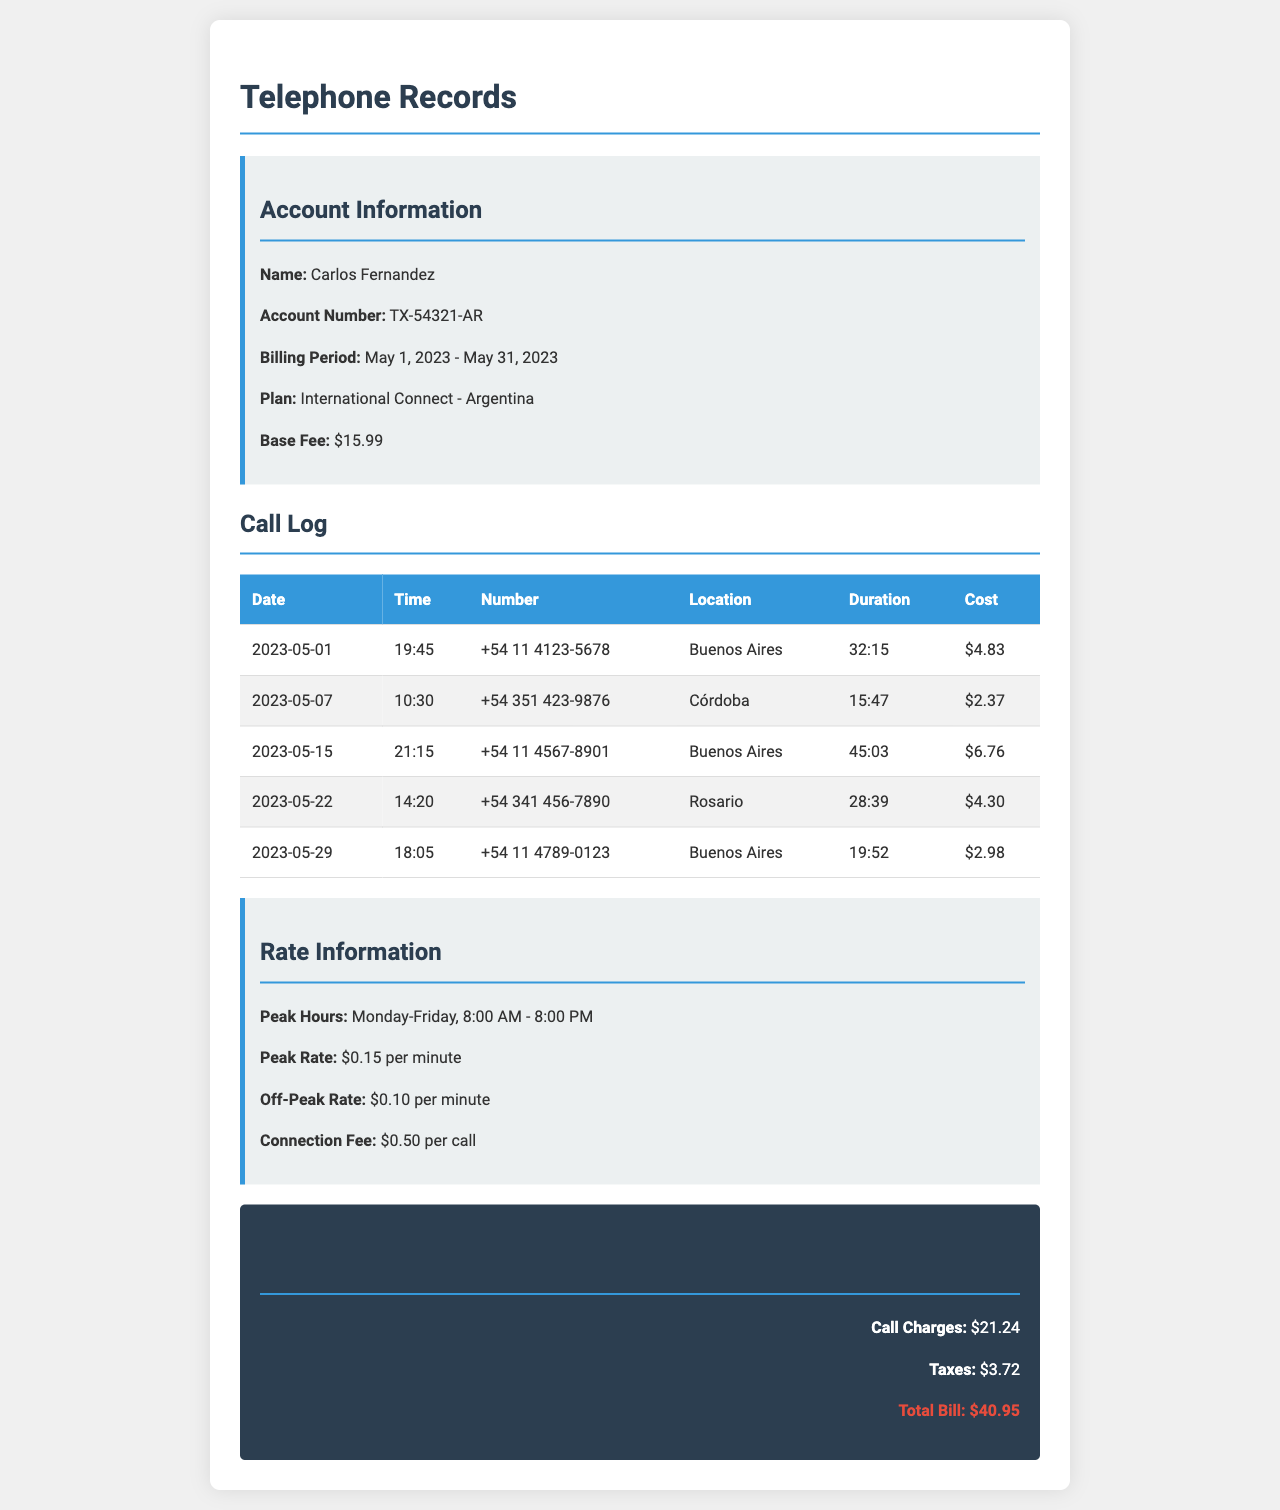What is the account number? The account number is found under the account information section, specifically labeled as such.
Answer: TX-54321-AR What was the total call charges? The total call charges are listed in the total charges section of the document.
Answer: $21.24 How many calls were made on May 15? The log indicates multiple calls on this date but only one specific call is listed, hence asking for that total.
Answer: 1 What is the cost of the longest call? The cost related to the longest call, which is also mentioned in the log next to its duration.
Answer: $6.76 What is the peak rate per minute? This information can be found in the rate section of the document under peak rate.
Answer: $0.15 per minute How long was the shortest call? The duration of the shortest call is shown in the call log and is easy to identify.
Answer: 15:47 What city was called on May 29? The location of the call made on this date is included in the call log as well.
Answer: Buenos Aires What is the total bill amount? The total bill amount is explicitly stated in the total charges section.
Answer: $40.95 